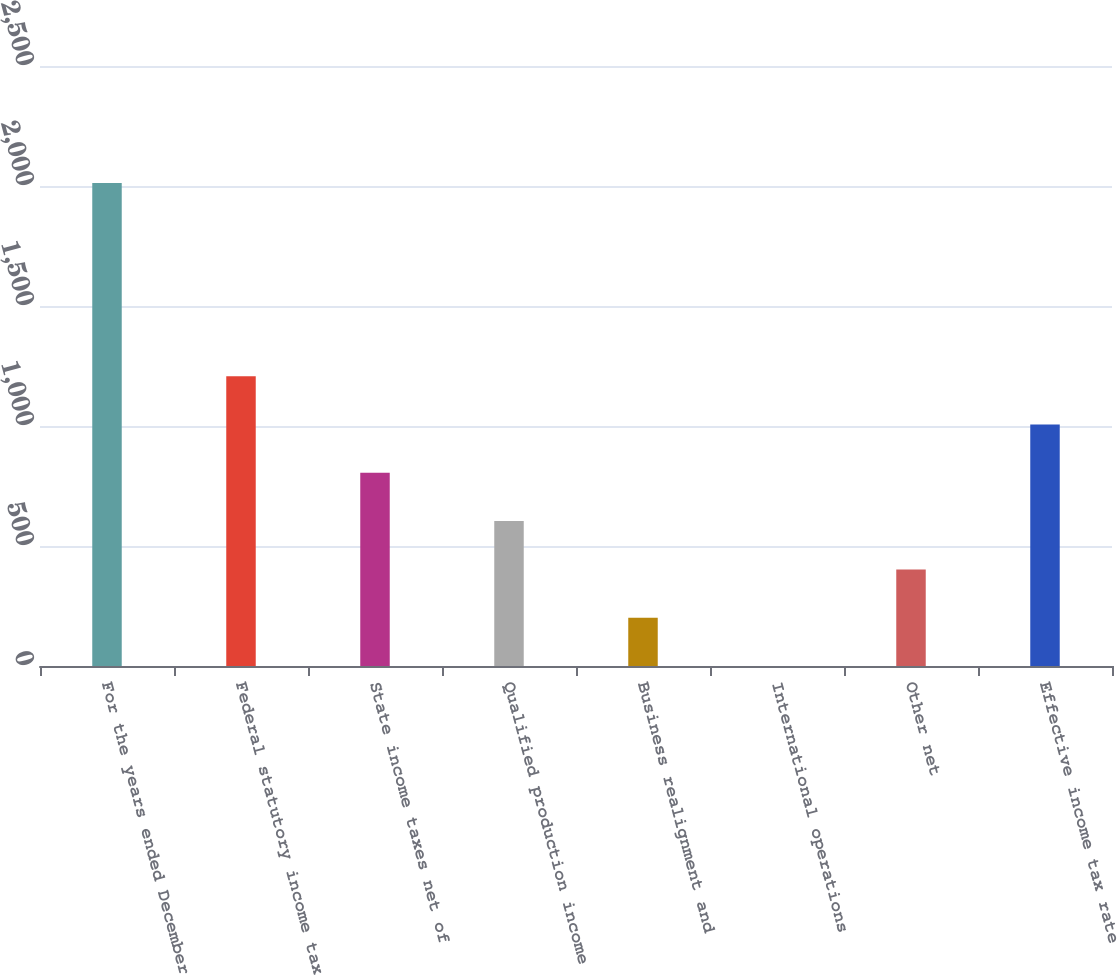Convert chart to OTSL. <chart><loc_0><loc_0><loc_500><loc_500><bar_chart><fcel>For the years ended December<fcel>Federal statutory income tax<fcel>State income taxes net of<fcel>Qualified production income<fcel>Business realignment and<fcel>International operations<fcel>Other net<fcel>Effective income tax rate<nl><fcel>2012<fcel>1207.24<fcel>804.86<fcel>603.67<fcel>201.29<fcel>0.1<fcel>402.48<fcel>1006.05<nl></chart> 